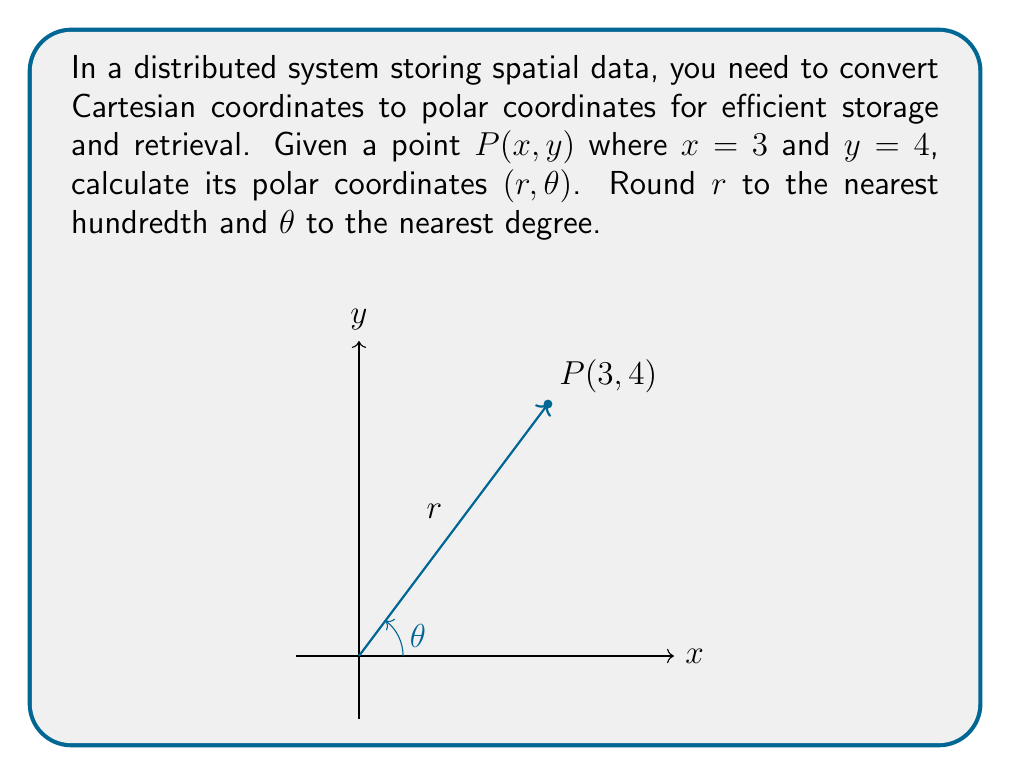Can you solve this math problem? To convert Cartesian coordinates $(x, y)$ to polar coordinates $(r, \theta)$, we use the following formulas:

1. $r = \sqrt{x^2 + y^2}$
2. $\theta = \arctan(\frac{y}{x})$

Step 1: Calculate $r$
$$r = \sqrt{x^2 + y^2} = \sqrt{3^2 + 4^2} = \sqrt{9 + 16} = \sqrt{25} = 5$$

Step 2: Calculate $\theta$
$$\theta = \arctan(\frac{y}{x}) = \arctan(\frac{4}{3}) \approx 0.9272952180 \text{ radians}$$

Step 3: Convert $\theta$ from radians to degrees
$$\theta \text{ (in degrees)} = 0.9272952180 \times \frac{180°}{\pi} \approx 53.13010235°$$

Step 4: Round $r$ to the nearest hundredth and $\theta$ to the nearest degree
$r \approx 5.00$
$\theta \approx 53°$
Answer: $(5.00, 53°)$ 